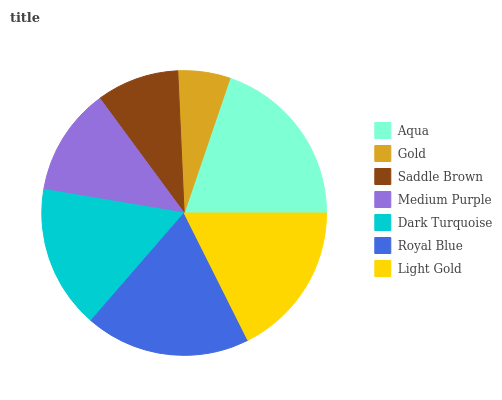Is Gold the minimum?
Answer yes or no. Yes. Is Aqua the maximum?
Answer yes or no. Yes. Is Saddle Brown the minimum?
Answer yes or no. No. Is Saddle Brown the maximum?
Answer yes or no. No. Is Saddle Brown greater than Gold?
Answer yes or no. Yes. Is Gold less than Saddle Brown?
Answer yes or no. Yes. Is Gold greater than Saddle Brown?
Answer yes or no. No. Is Saddle Brown less than Gold?
Answer yes or no. No. Is Dark Turquoise the high median?
Answer yes or no. Yes. Is Dark Turquoise the low median?
Answer yes or no. Yes. Is Light Gold the high median?
Answer yes or no. No. Is Saddle Brown the low median?
Answer yes or no. No. 